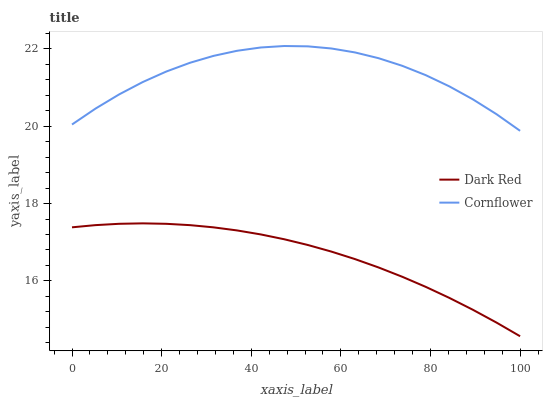Does Cornflower have the minimum area under the curve?
Answer yes or no. No. Is Cornflower the smoothest?
Answer yes or no. No. Does Cornflower have the lowest value?
Answer yes or no. No. Is Dark Red less than Cornflower?
Answer yes or no. Yes. Is Cornflower greater than Dark Red?
Answer yes or no. Yes. Does Dark Red intersect Cornflower?
Answer yes or no. No. 